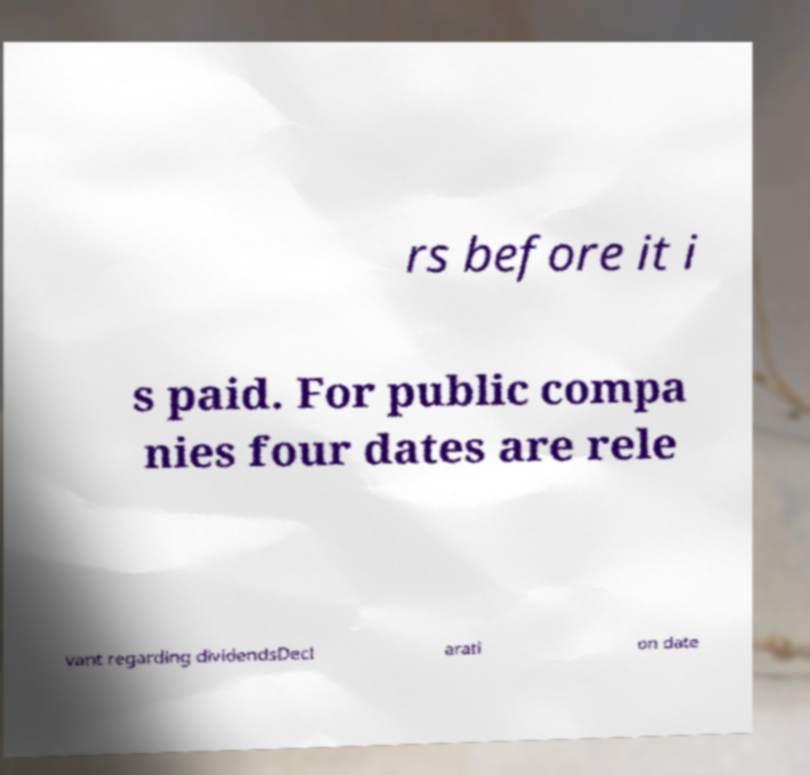I need the written content from this picture converted into text. Can you do that? rs before it i s paid. For public compa nies four dates are rele vant regarding dividendsDecl arati on date 